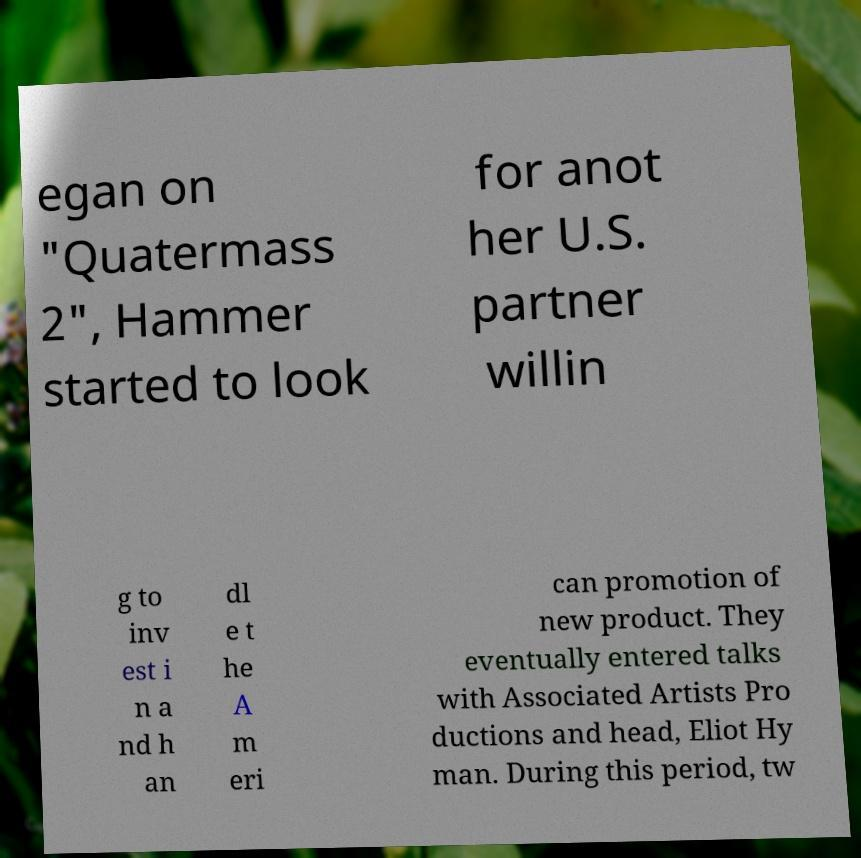There's text embedded in this image that I need extracted. Can you transcribe it verbatim? egan on "Quatermass 2", Hammer started to look for anot her U.S. partner willin g to inv est i n a nd h an dl e t he A m eri can promotion of new product. They eventually entered talks with Associated Artists Pro ductions and head, Eliot Hy man. During this period, tw 